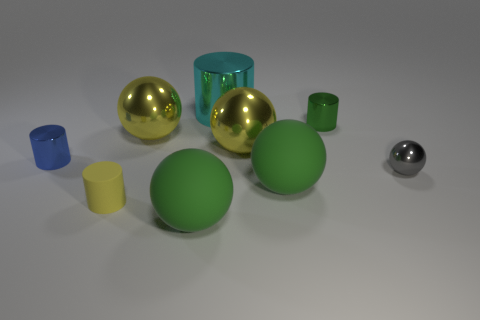Subtract all small gray balls. How many balls are left? 4 Add 1 green metallic objects. How many objects exist? 10 Subtract all brown cylinders. How many green balls are left? 2 Subtract all cyan cylinders. How many cylinders are left? 3 Subtract all small rubber things. Subtract all large cylinders. How many objects are left? 7 Add 7 big yellow spheres. How many big yellow spheres are left? 9 Add 6 big gray spheres. How many big gray spheres exist? 6 Subtract 1 cyan cylinders. How many objects are left? 8 Subtract all cylinders. How many objects are left? 5 Subtract 3 cylinders. How many cylinders are left? 1 